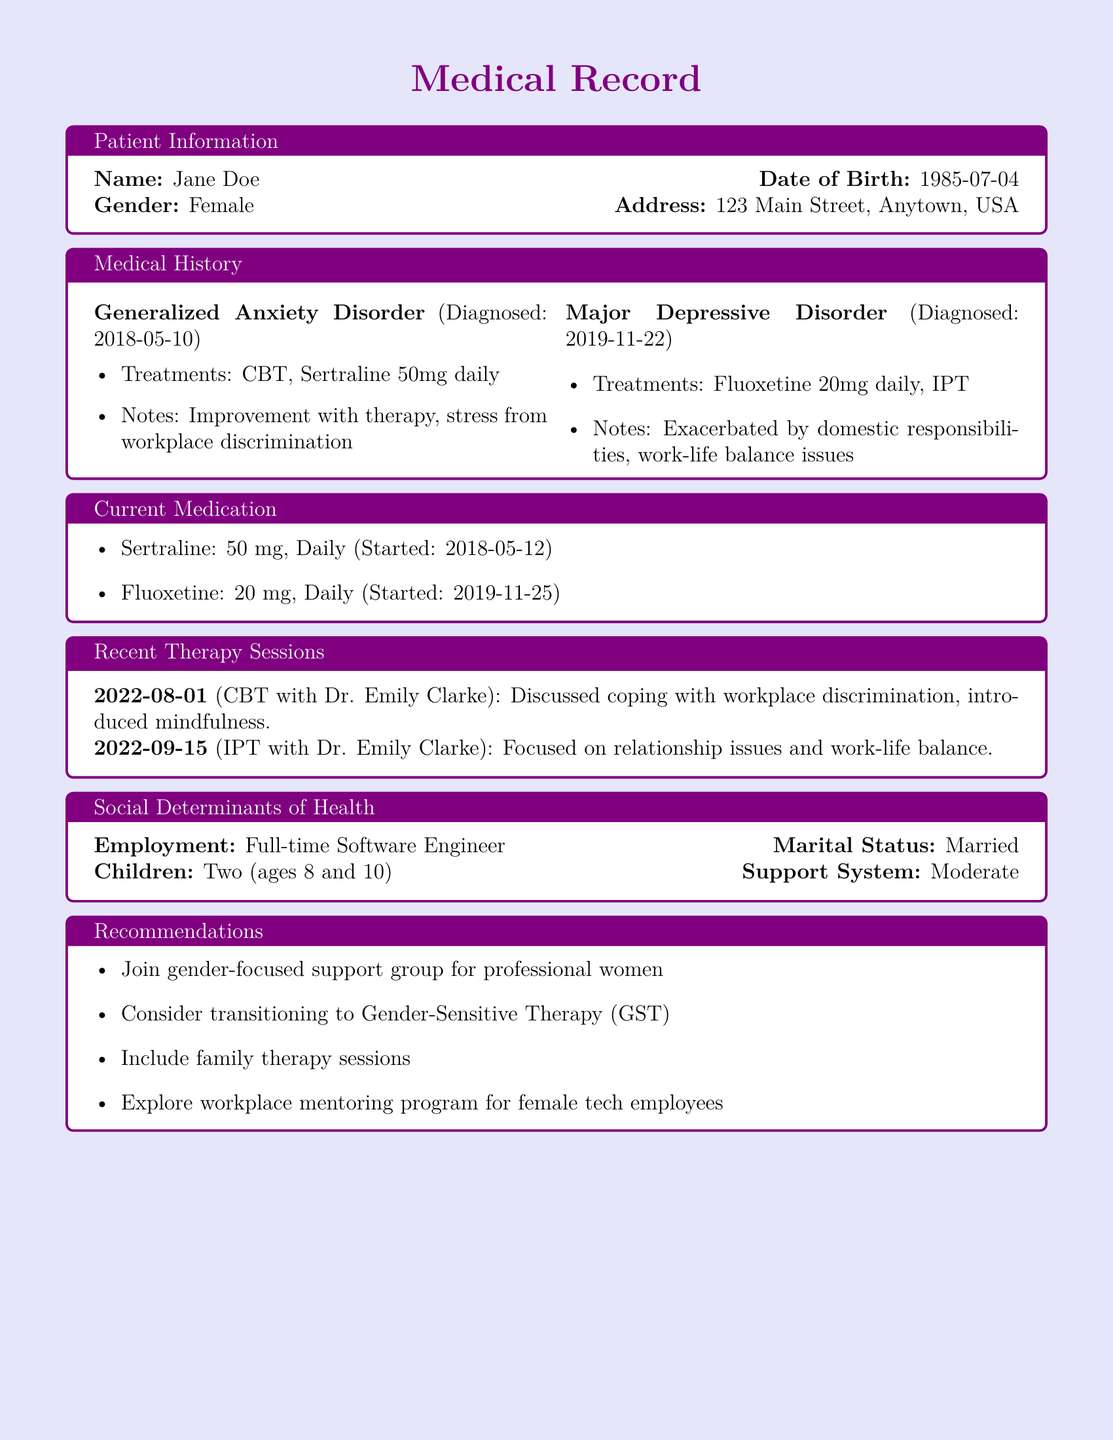What is the name of the patient? The patient's name is specifically mentioned in the document within the patient information section.
Answer: Jane Doe What medications is the patient currently taking? The current medication section lists the medications the patient is taking.
Answer: Sertraline, Fluoxetine When was the Generalized Anxiety Disorder diagnosed? The medical history section specifies the date of diagnosis for Generalized Anxiety Disorder.
Answer: 2018-05-10 What therapy type was included in the recent therapy sessions? The recent therapy sessions detail the types of therapy conducted with the patient.
Answer: CBT, IPT What is one of the social determinants of health listed for the patient? The social determinants of health section includes various factors affecting the patient's health.
Answer: Employment What recommendation is made for the patient regarding therapy? The recommendations section suggests specific actions for the patient's treatment plan.
Answer: Transitioning to Gender-Sensitive Therapy What is the marital status of the patient? The social determinants of health segment provides personal information such as marital status.
Answer: Married What specific issue was discussed in the therapy session on 2022-08-01? The recent therapy sessions outline specific topics discussed during those meetings.
Answer: Workplace discrimination How many children does the patient have? The social determinants of health section provides the number of children.
Answer: Two 